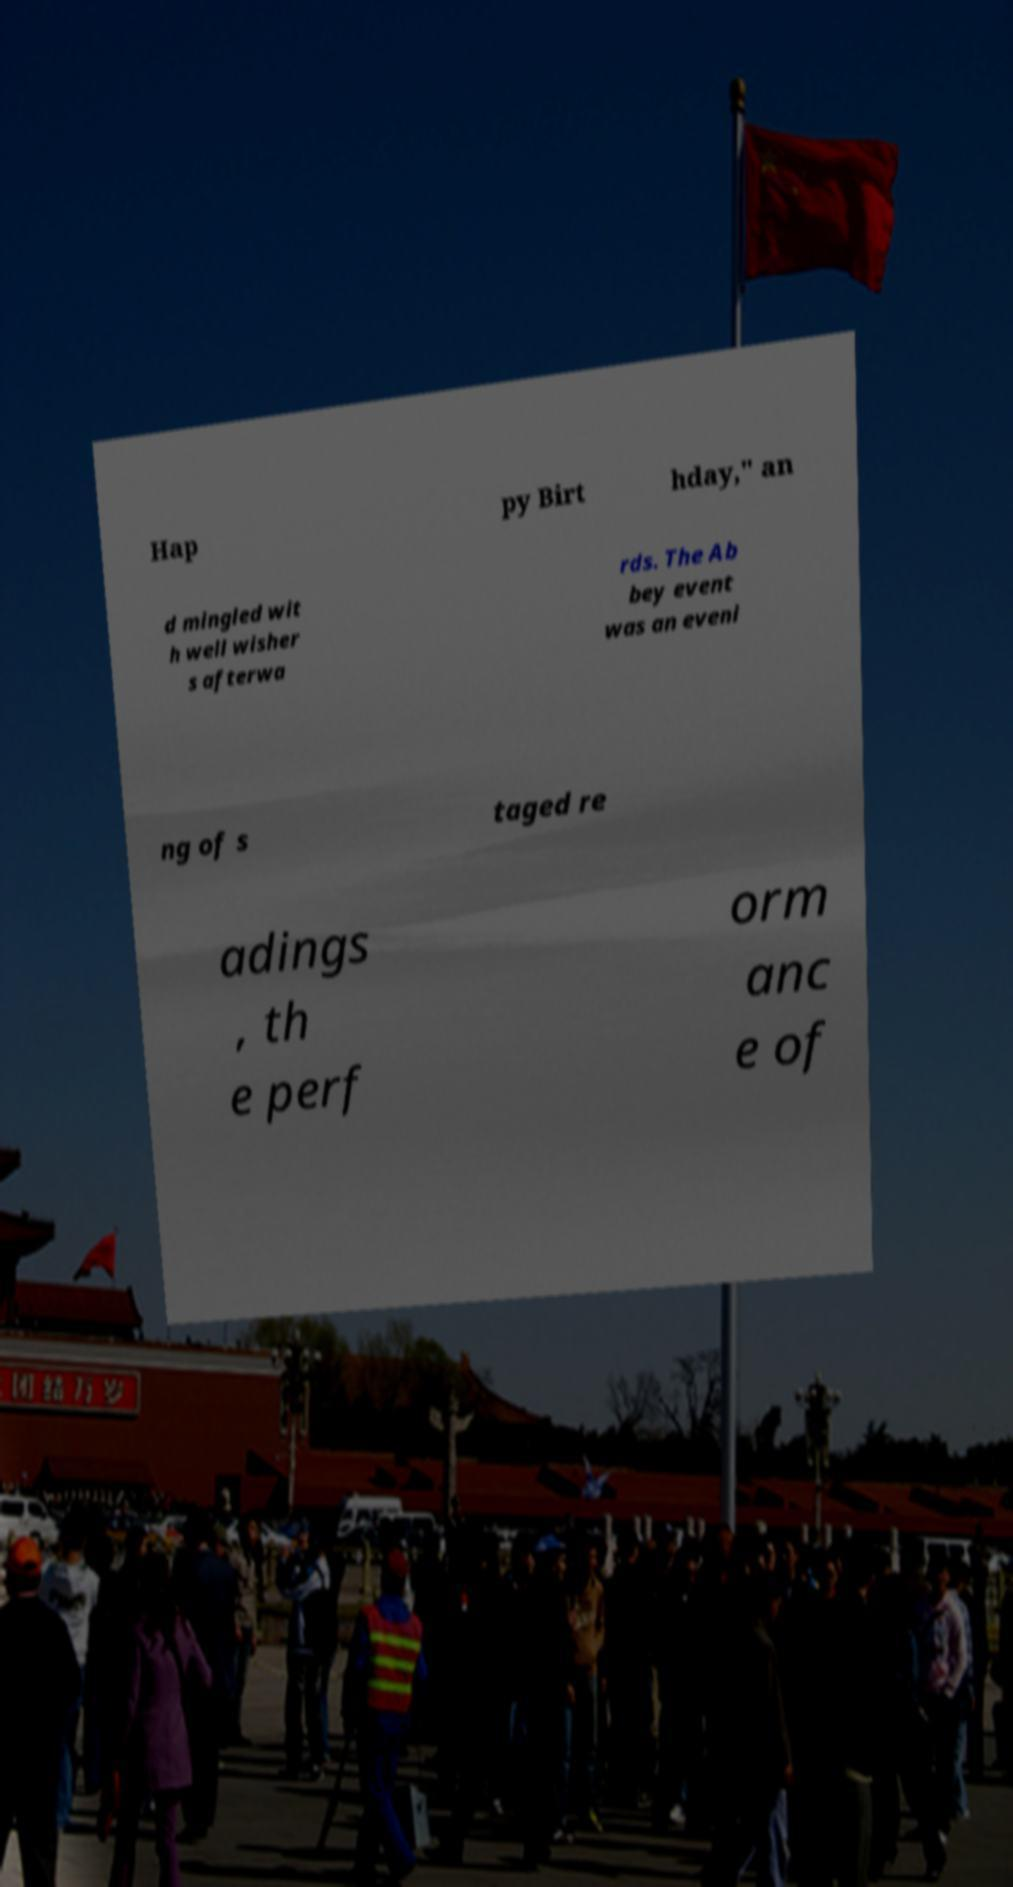Can you accurately transcribe the text from the provided image for me? Hap py Birt hday," an d mingled wit h well wisher s afterwa rds. The Ab bey event was an eveni ng of s taged re adings , th e perf orm anc e of 